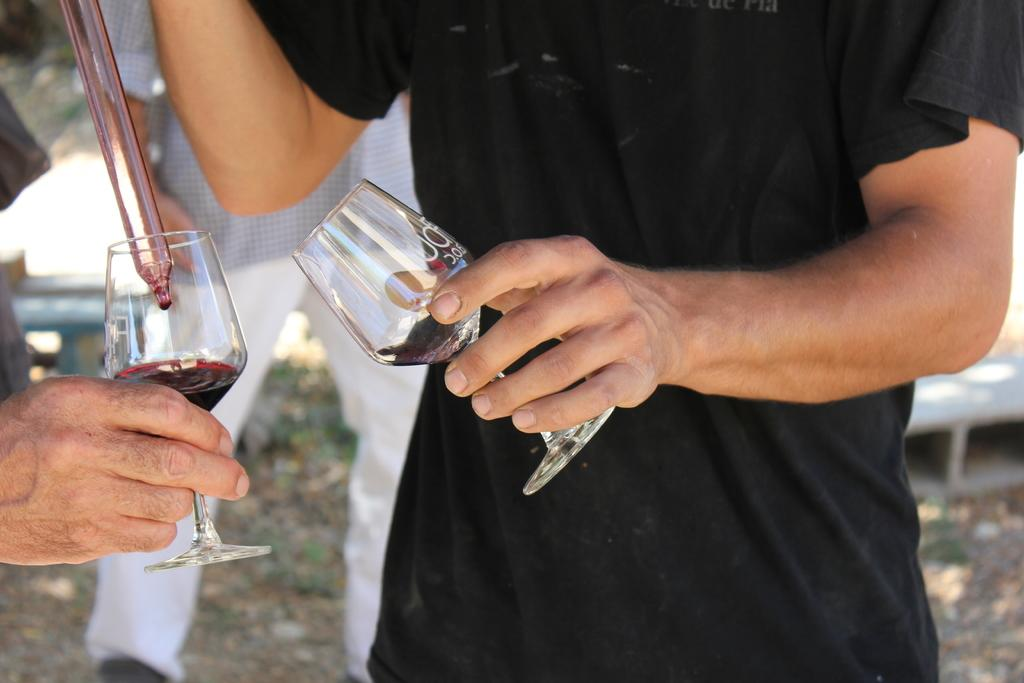What are the humans holding in the image? The humans are holding glasses in the image. Can you describe any other objects in the image? Yes, there is a glass tube in the image. Are there any other people visible in the image? Yes, there is another human standing in the background of the image. What type of print can be seen on the throne in the image? There is no throne present in the image. 